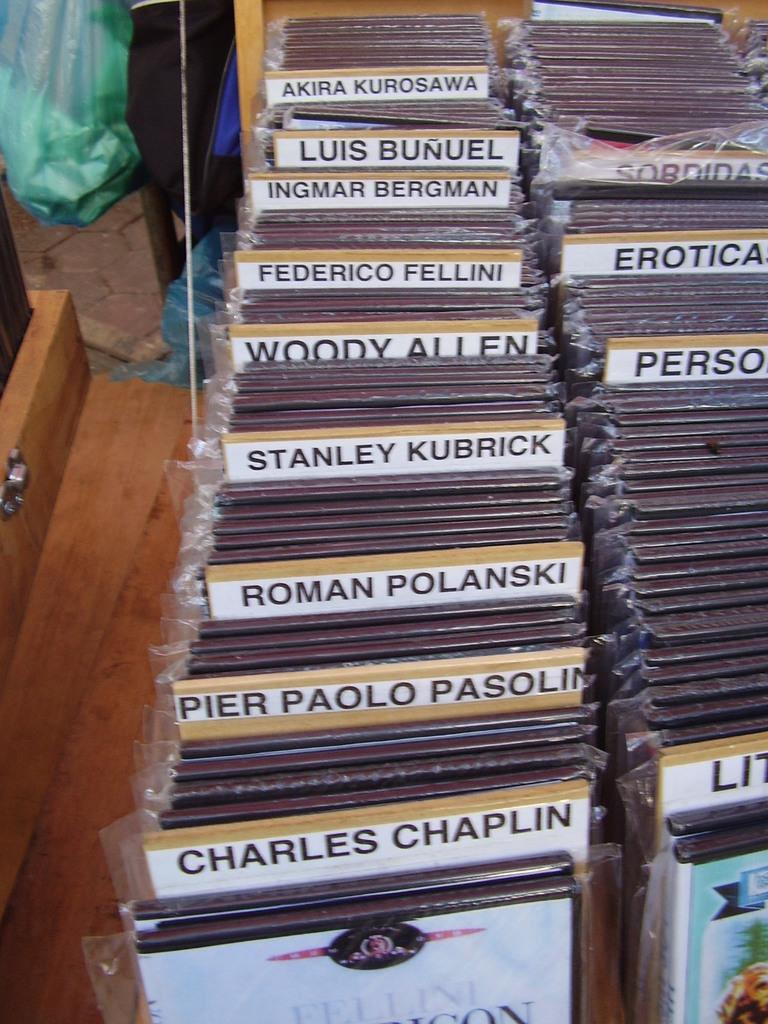<image>
Write a terse but informative summary of the picture. A label in the left row with Woody Allen written on it. 